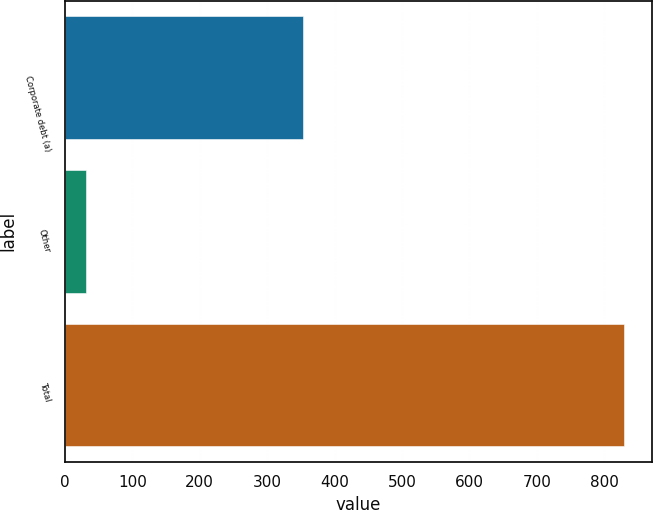<chart> <loc_0><loc_0><loc_500><loc_500><bar_chart><fcel>Corporate debt (a)<fcel>Other<fcel>Total<nl><fcel>353<fcel>31<fcel>829<nl></chart> 